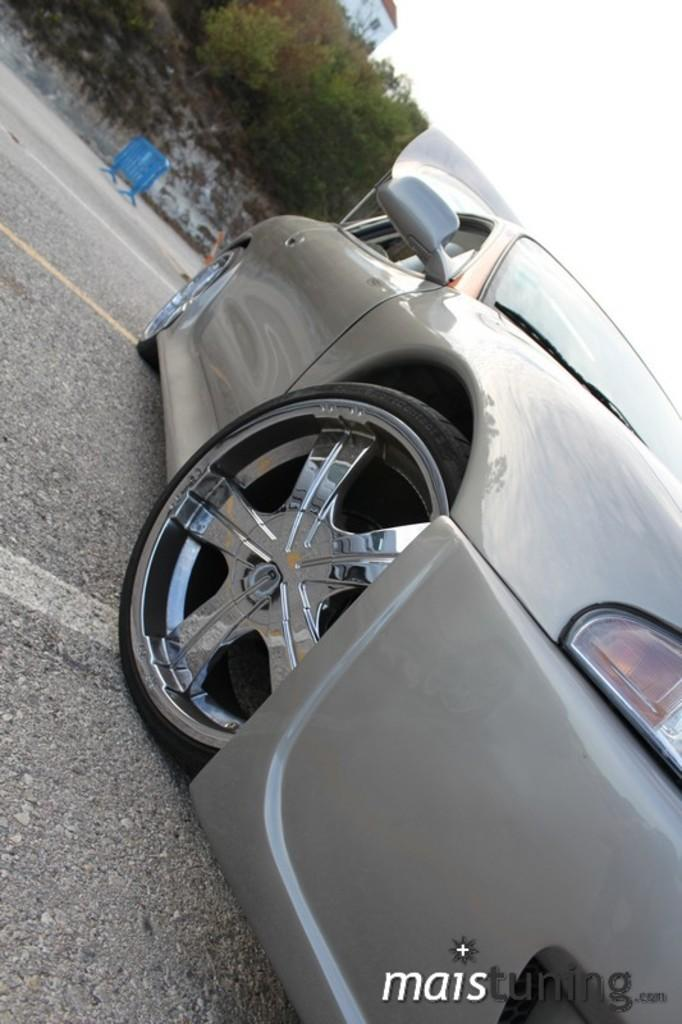What is the main subject of the image? There is a vehicle on the ground in the image. What can be seen in the background of the image? There is a fence, trees, a house, and the sky visible in the background of the image. Where is the text located in the image? The text is in the bottom right corner of the image. What type of mint is growing near the house in the image? There is no mint present in the image; the background features trees, not mint plants. 